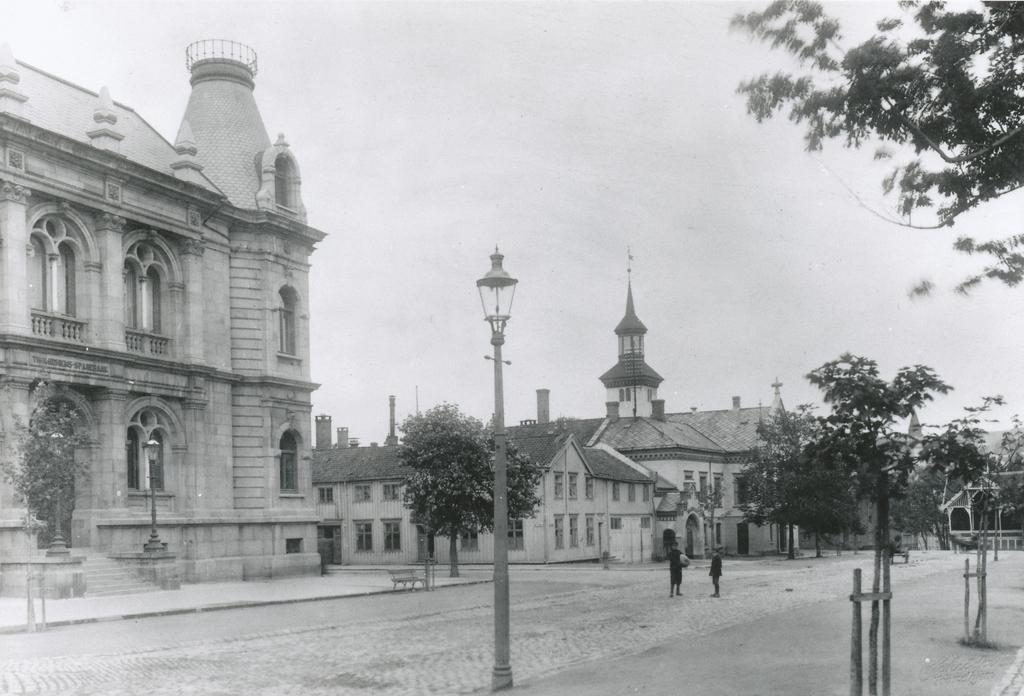How many people are standing on the road in the image? There are two people standing on the road in the image. What else can be seen in the image besides the people on the road? Buildings, trees, a street light, and the sky are visible in the image. Can you describe the street light in the image? The street light is present in the image, providing illumination on the road. What is visible at the top of the image? The sky is visible at the top of the image. What type of jeans is the band wearing in the image? There is no band present in the image, and therefore no one is wearing jeans. 